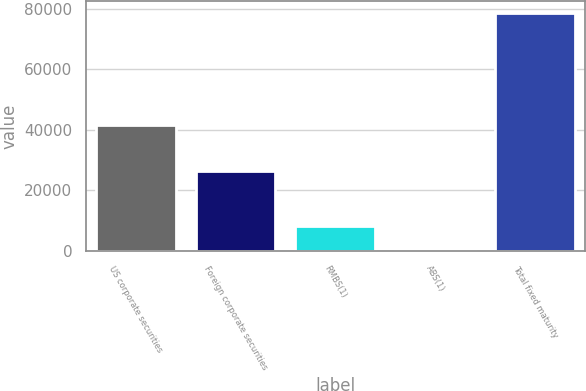Convert chart to OTSL. <chart><loc_0><loc_0><loc_500><loc_500><bar_chart><fcel>US corporate securities<fcel>Foreign corporate securities<fcel>RMBS(1)<fcel>ABS(1)<fcel>Total fixed maturity<nl><fcel>41533<fcel>26383<fcel>8172.6<fcel>355<fcel>78531<nl></chart> 